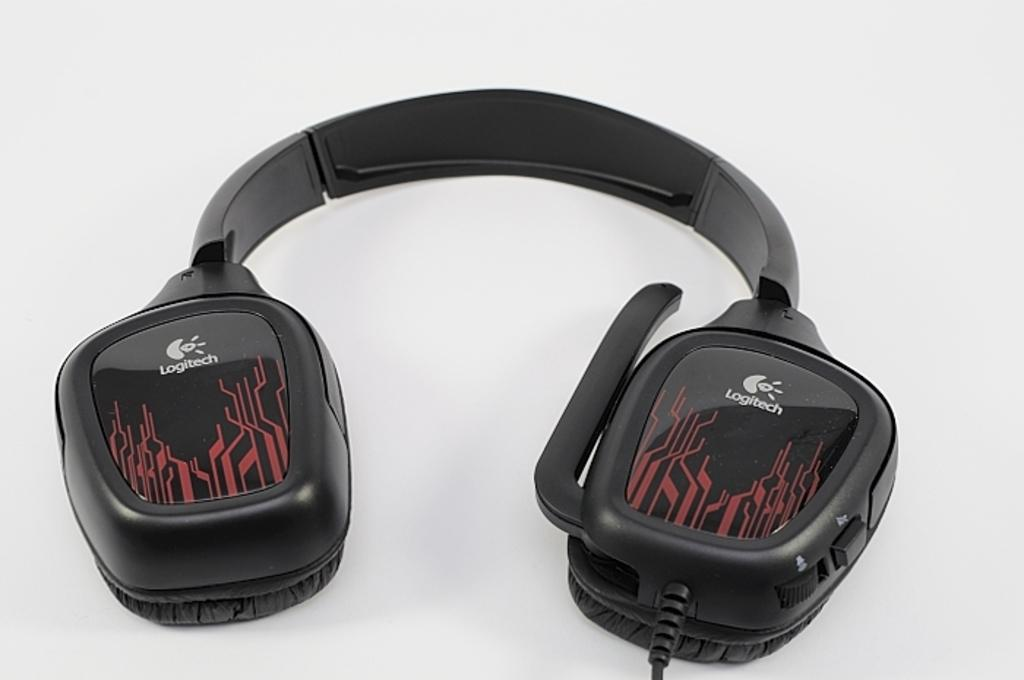<image>
Offer a succinct explanation of the picture presented. Large Logitech headphones with a red pattern on each side. 